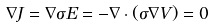Convert formula to latex. <formula><loc_0><loc_0><loc_500><loc_500>\nabla J = \nabla \sigma E = - \nabla \cdot ( \sigma \nabla V ) = 0</formula> 